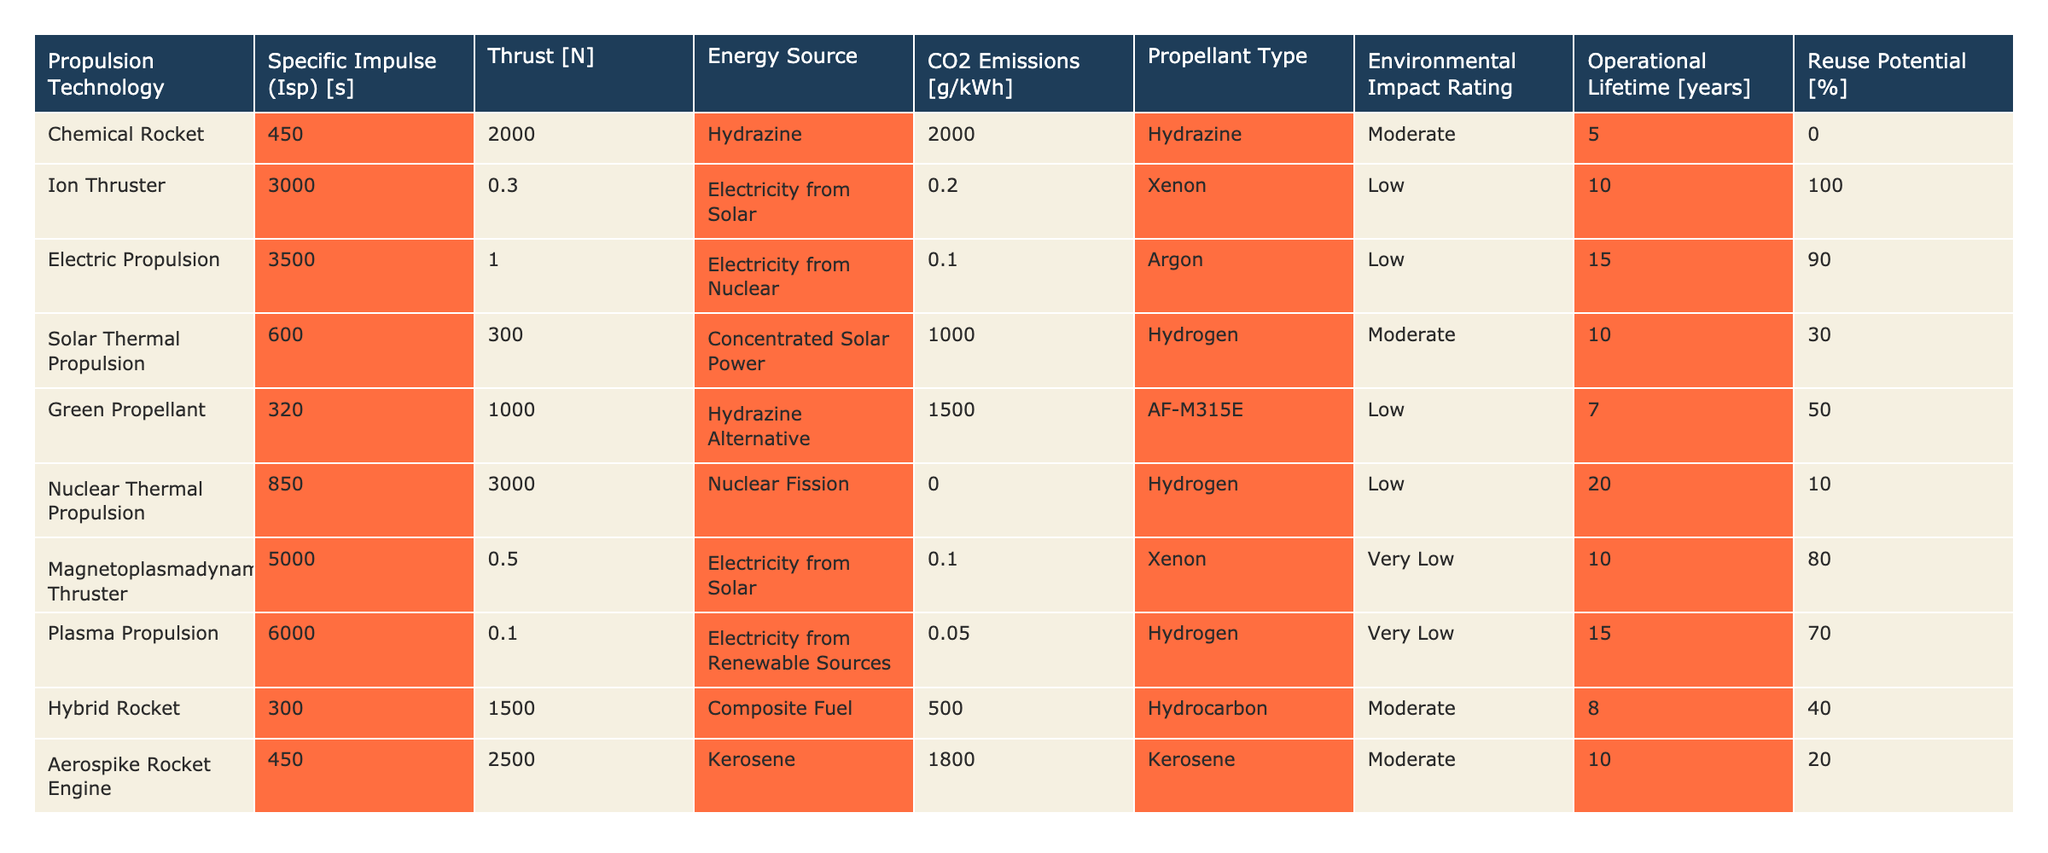What is the specific impulse of the Plasma Propulsion technology? The table lists the specific impulse for each propulsion technology. For Plasma Propulsion, it is stated as 6000 seconds.
Answer: 6000 seconds Which propulsion technology has the lowest CO2 emissions? The table shows CO2 emissions for each technology. Electric Propulsion has the lowest emissions at 0.1 g/kWh.
Answer: 0.1 g/kWh What is the reuse potential of the Ion Thruster? Looking at the reuse potential column for Ion Thruster, it indicates that it is 100%.
Answer: 100% Which propulsion technology has the highest thrust? The thrust values for each technology indicate that Nuclear Thermal Propulsion has the highest thrust at 3000 N.
Answer: 3000 N What is the average operational lifetime of the propulsion technologies listed? The operational lifetimes are: 5, 10, 15, 10, 7, 20, 10, 15, 8, and 10 years. Summing these gives 105 years. Dividing by the number of technologies (10) results in an average of 10.5 years.
Answer: 10.5 years Is the Environmental Impact Rating of the Hybrid Rocket better than that of the Chemical Rocket? The Environmental Impact Ratings show that the Hybrid Rocket is rated as Moderate, while the Chemical Rocket is also rated as Moderate. Therefore, they are the same.
Answer: No Which energy source is used by the Magnetoplasmadynamic Thruster? The table states that Magnetoplasmadynamic Thruster uses 'Electricity from Solar' as its energy source.
Answer: Electricity from Solar What is the difference in CO2 emissions between the Aerospike Rocket Engine and the Green Propellant? The CO2 emissions for the Aerospike Rocket Engine is 1800 g/kWh and for the Green Propellant is 1500 g/kWh. The difference is 1800 - 1500 = 300 g/kWh.
Answer: 300 g/kWh Identify the propulsion technology with the highest environmental impact rating. The Environmental Impact Ratings list 'Very Low', 'Low', and 'Moderate'. The highest rating among these is Moderate, which applies to Chemical Rocket, Solar Thermal Propulsion, Hybrid Rocket, and Aerospike Rocket Engine. Therefore, there are multiple technologies with the highest rating.
Answer: Chemical Rocket, Solar Thermal Propulsion, Hybrid Rocket, Aerospike Rocket Engine How does the thrust of Electric Propulsion compare to Ion Thruster? Electric Propulsion has a thrust of 1 N, while Ion Thruster has 0.3 N. Comparing these values, Electric Propulsion has a higher thrust than the Ion Thruster.
Answer: Higher 